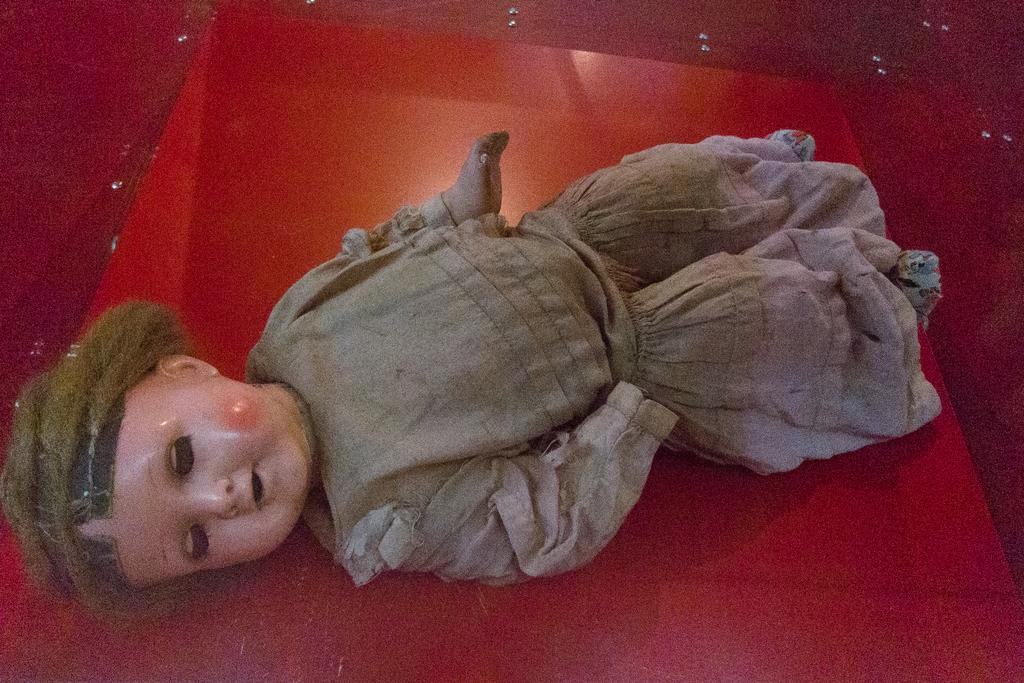What is placed on the red surface in the image? There is a doll placed on a red surface. What color dominates the image? The remaining portion of the picture is in red color. Are there any ants crawling on the leather surface in the image? There are no ants or leather surfaces present in the image; it features a doll placed on a red surface. 